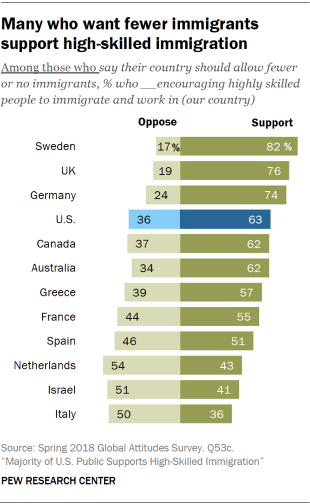Specify some key components in this picture. Sweden has the highest support rate among all countries. According to the data, there are currently nine countries that have supporting ratings over 50%. 